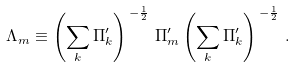<formula> <loc_0><loc_0><loc_500><loc_500>\Lambda _ { m } & \equiv \left ( \sum _ { k } \Pi _ { k } ^ { \prime } \right ) ^ { \, - \frac { 1 } { 2 } } \, \Pi _ { m } ^ { \prime } \left ( \sum _ { k } \Pi _ { k } ^ { \prime } \right ) ^ { \, - \frac { 1 } { 2 } } \, .</formula> 